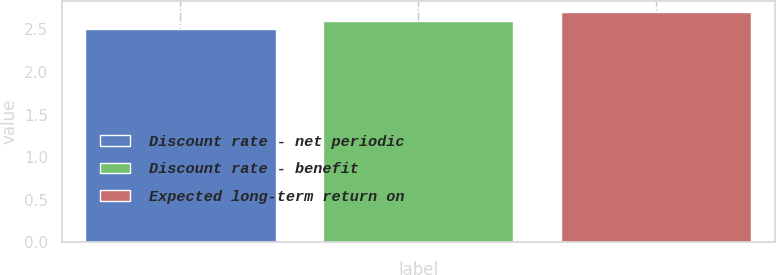Convert chart to OTSL. <chart><loc_0><loc_0><loc_500><loc_500><bar_chart><fcel>Discount rate - net periodic<fcel>Discount rate - benefit<fcel>Expected long-term return on<nl><fcel>2.5<fcel>2.6<fcel>2.7<nl></chart> 